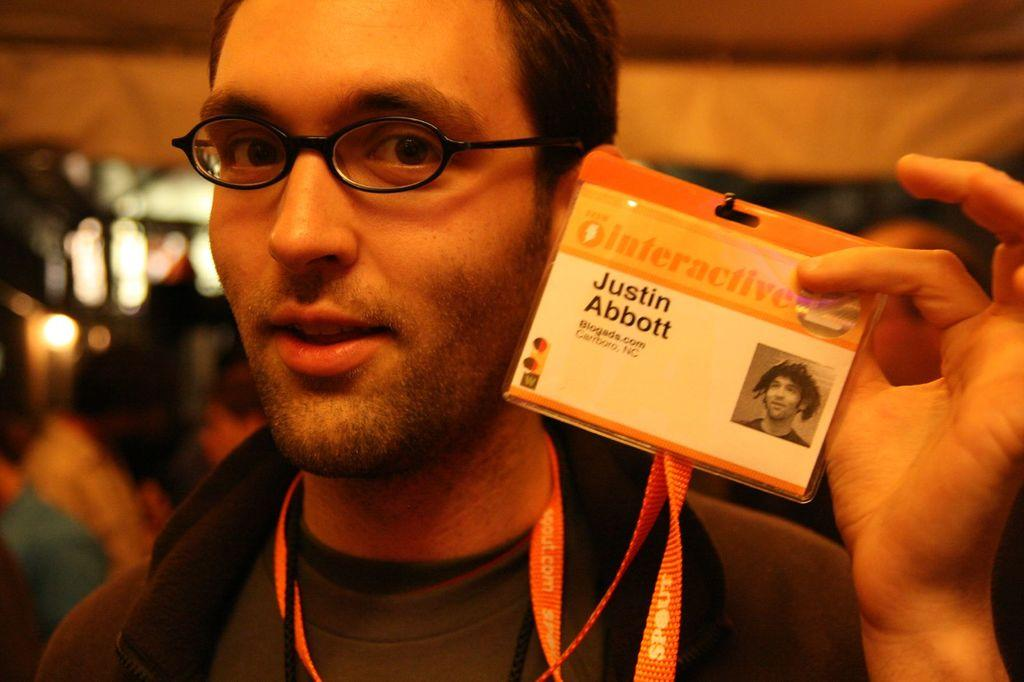What is the main subject of the image? There is a man in the image. What is the man's facial expression? The man has a smiling face. What is the man wearing in the image? The man is wearing an ID card. What is the man doing with the ID card? The man is holding the ID card. Can you describe the background of the image? There are objects and people in the background of the image, and the background is blurred. How many houses can be seen in the man's pocket in the image? There are no houses visible in the image, let alone in the man's pocket. 